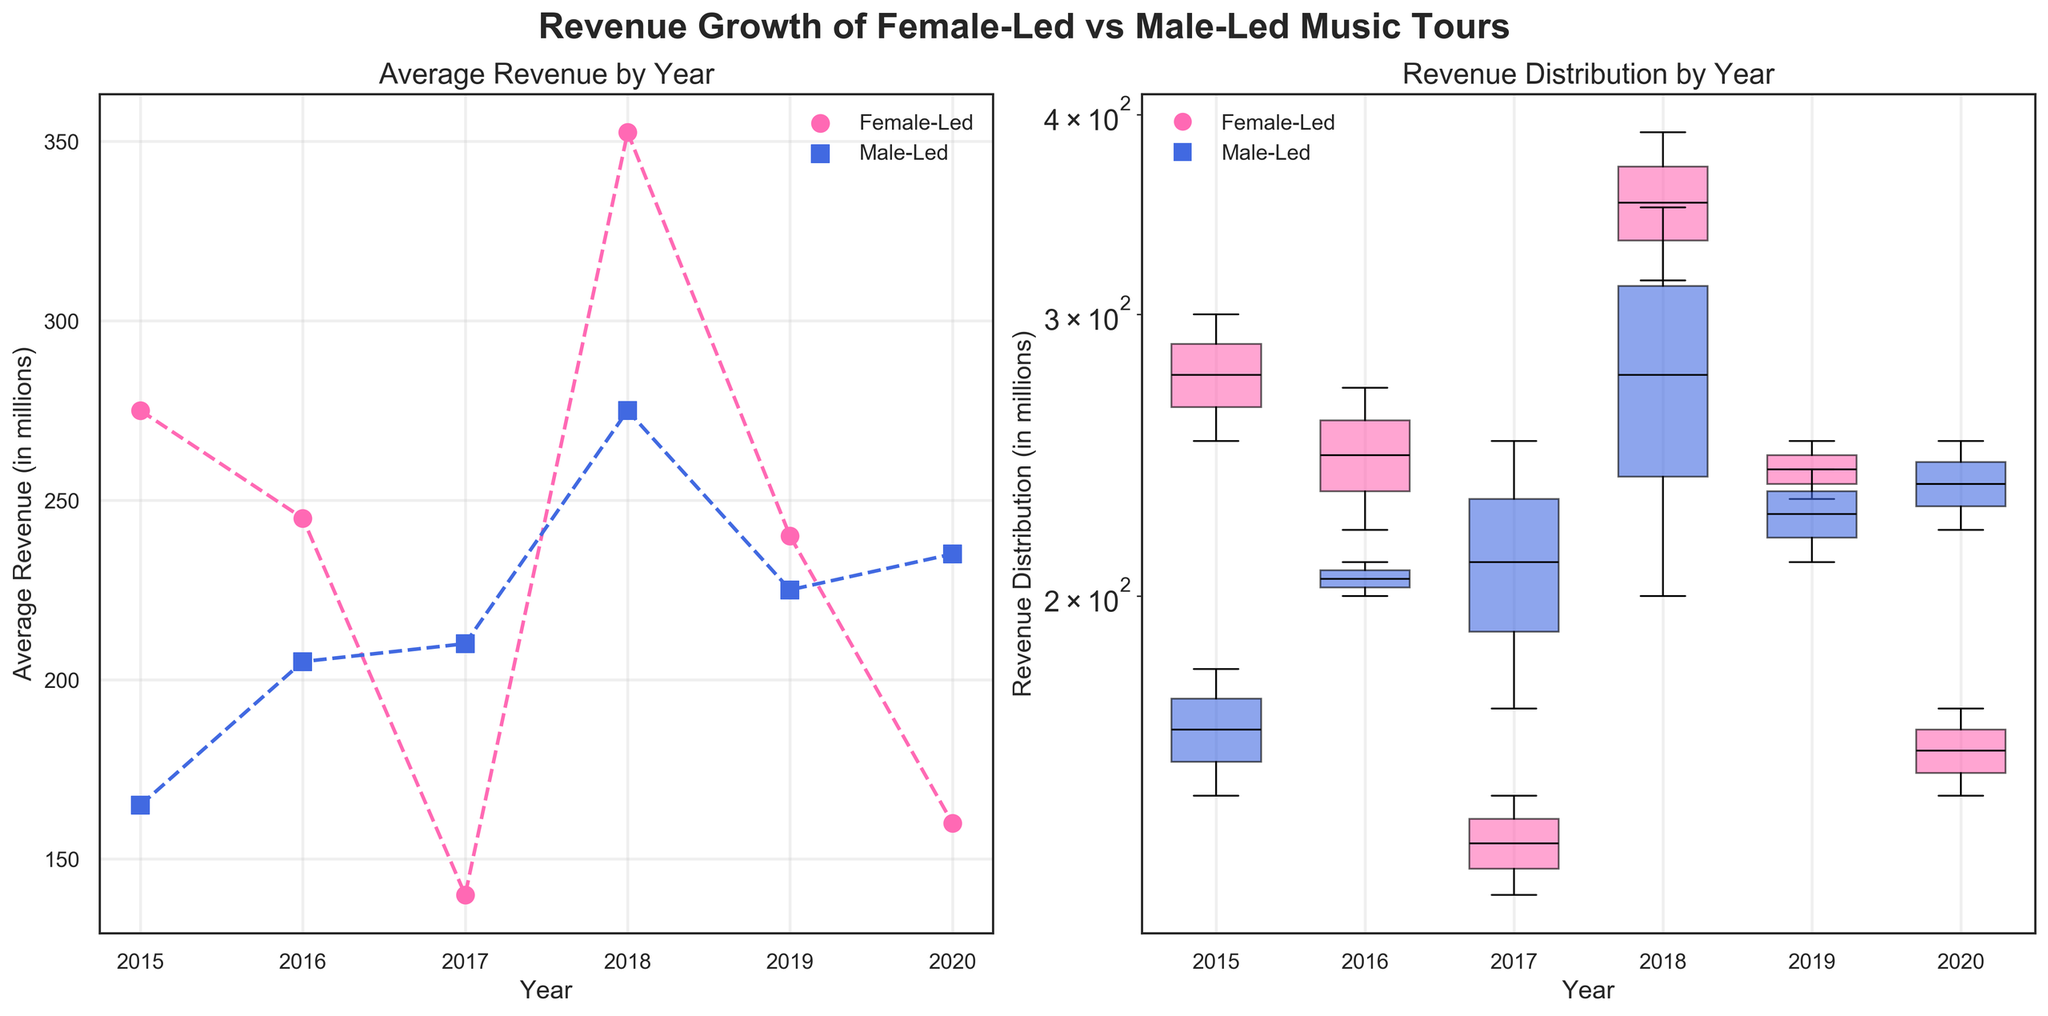What is the title of the plot? The title of the plot is positioned at the top center of the figure. It reads "Revenue Growth of Female-Led vs Male-Led Music Tours."
Answer: Revenue Growth of Female-Led vs Male-Led Music Tours Which color represents Female-Led artists in the plots? In the plots, Female-Led artists are represented by the color pink. This can be inferred from the color legend and the label of the data points.
Answer: Pink What does the x-axis represent in the left subplot? The x-axis in the left subplot represents the years. You can see this from the axis label "Year" and the numerical years marked on it.
Answer: Year How is the revenue represented in the right subplot? In the right subplot, the revenue is shown as a distribution using boxplots, and the y-axis is on a logarithmic scale. You can tell by the boxplot shapes and the y-axis label.
Answer: Boxplots with log scale Which year had the highest average revenue for Female-Led artists? In the left subplot, the Female-Led artists are represented by the pink dashed line. The average revenue peaks in 2018 according to the line's highest point.
Answer: 2018 Compare the median revenue of Male-Led artists in 2017 and 2018. Which is higher? In the right subplot, he boxes for Male-Led artists in 2017 and 2018 are blue, with median lines in 2018 appears higher than the median in 2017.
Answer: 2018 What is the average revenue for Male-Led artists in 2020? In the left subplot, look for the data point on the Male-Led line (blue dashed line) corresponding to 2020, which is around 235 million dollars.
Answer: 235 million Do Female-Led artists show more variability in revenue than Male-Led artists in 2015? The right subplot shows boxplots for 2015. The Female-Led box (pink) has a wider range and longer whiskers compared to the Male-Led box (blue).
Answer: Yes Summarize the overall trend of Male-Led artists' revenue from 2015 to 2020. In the left subplot, observe the blue dashed line representing Male-Led artists. It shows a general upward trend in revenue despite some fluctuations.
Answer: Upward trend Why might a log scale be used on the y-axis of the right subplot? A logarithmic scale is often used when data spans several orders of magnitude, helping to visualize differences across a broad range of values. The revenue data ranges widely, justifying a log scale for clearer comparison.
Answer: Broad range of values 